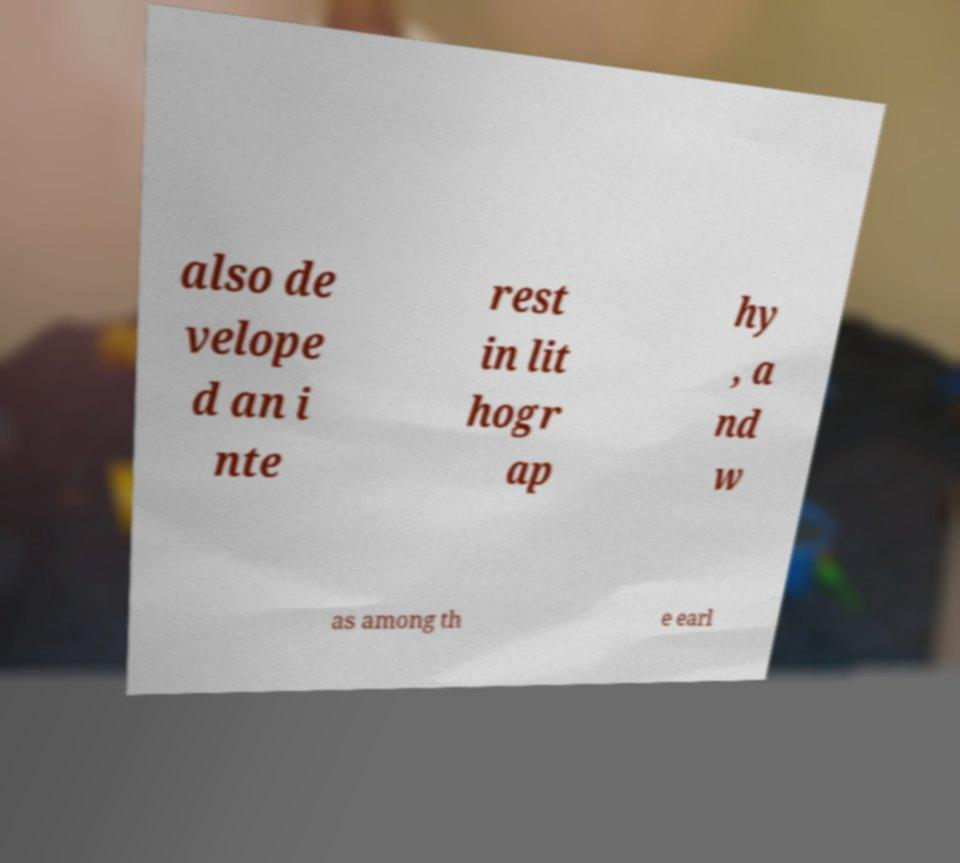What messages or text are displayed in this image? I need them in a readable, typed format. also de velope d an i nte rest in lit hogr ap hy , a nd w as among th e earl 